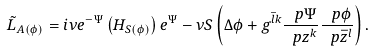Convert formula to latex. <formula><loc_0><loc_0><loc_500><loc_500>\tilde { L } _ { A ( \phi ) } = i \nu e ^ { - \Psi } \left ( H _ { S ( \phi ) } \right ) e ^ { \Psi } - \nu S \left ( \Delta \phi + g ^ { \bar { l } k } \frac { \ p \Psi } { \ p z ^ { k } } \frac { \ p \phi } { \ p \bar { z } ^ { l } } \right ) .</formula> 